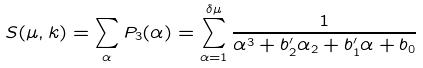Convert formula to latex. <formula><loc_0><loc_0><loc_500><loc_500>S ( \mu , k ) & = \sum _ { \alpha } P _ { 3 } ( \alpha ) = \sum _ { \alpha = 1 } ^ { \delta \mu } \frac { 1 } { \alpha ^ { 3 } + b ^ { \prime } _ { 2 } \alpha _ { 2 } + b ^ { \prime } _ { 1 } \alpha + b _ { 0 } }</formula> 